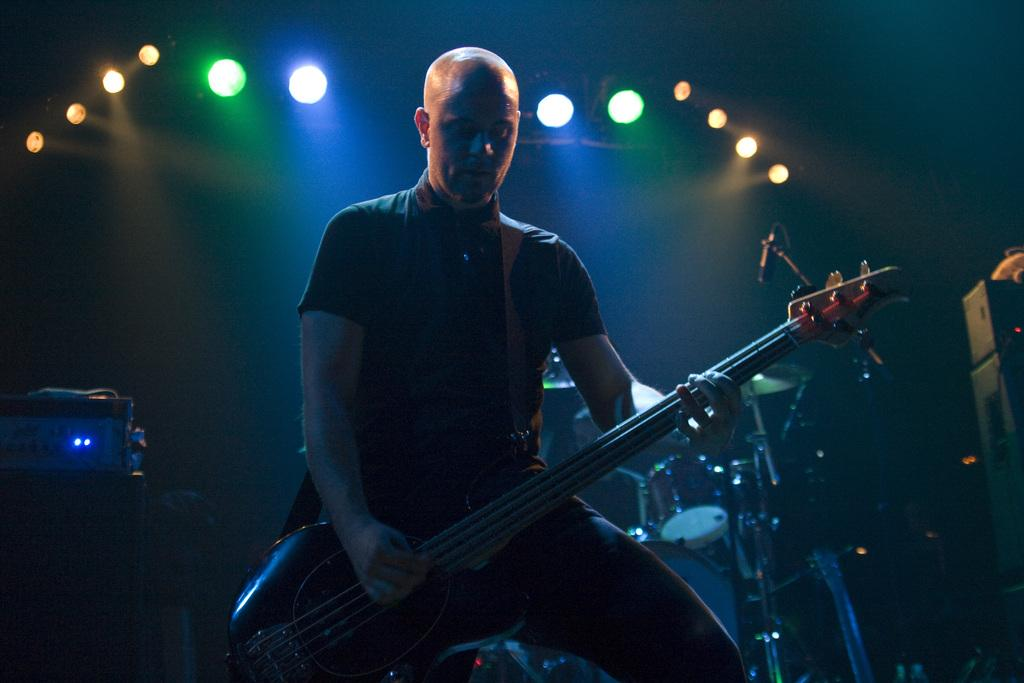Who is the main subject in the image? There is a man in the image. What is the man doing in the image? The man is sitting and playing a guitar. Are there any other musical instruments in the image besides the guitar? Yes, there are other musical instruments in the image. What type of sand can be seen in the image? There is no sand present in the image. Is there an umbrella visible in the image? No, there is no umbrella present in the image. 